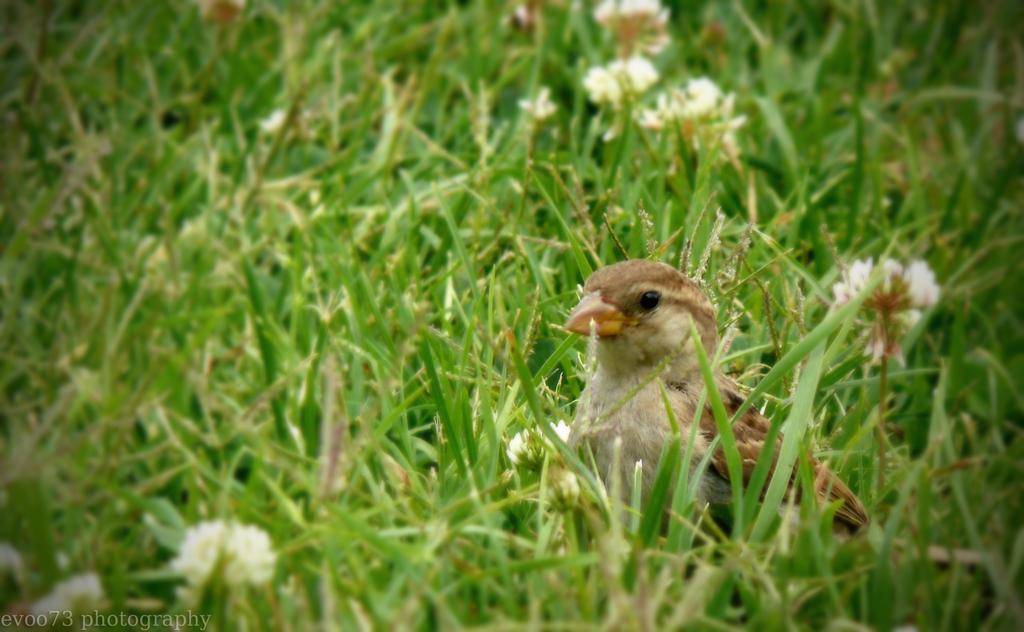In one or two sentences, can you explain what this image depicts? In this picture we can see a bird on the path and behind the bird there are plants with flowers and on the image there is a watermark. 